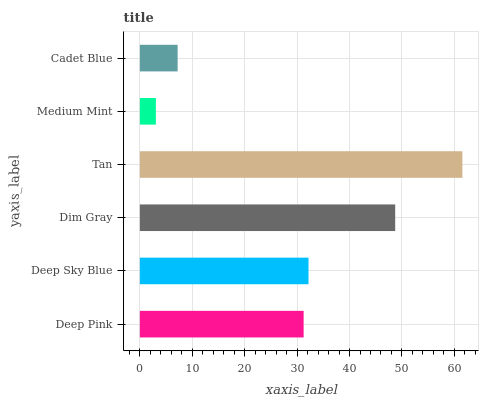Is Medium Mint the minimum?
Answer yes or no. Yes. Is Tan the maximum?
Answer yes or no. Yes. Is Deep Sky Blue the minimum?
Answer yes or no. No. Is Deep Sky Blue the maximum?
Answer yes or no. No. Is Deep Sky Blue greater than Deep Pink?
Answer yes or no. Yes. Is Deep Pink less than Deep Sky Blue?
Answer yes or no. Yes. Is Deep Pink greater than Deep Sky Blue?
Answer yes or no. No. Is Deep Sky Blue less than Deep Pink?
Answer yes or no. No. Is Deep Sky Blue the high median?
Answer yes or no. Yes. Is Deep Pink the low median?
Answer yes or no. Yes. Is Deep Pink the high median?
Answer yes or no. No. Is Dim Gray the low median?
Answer yes or no. No. 